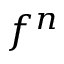<formula> <loc_0><loc_0><loc_500><loc_500>f ^ { n }</formula> 